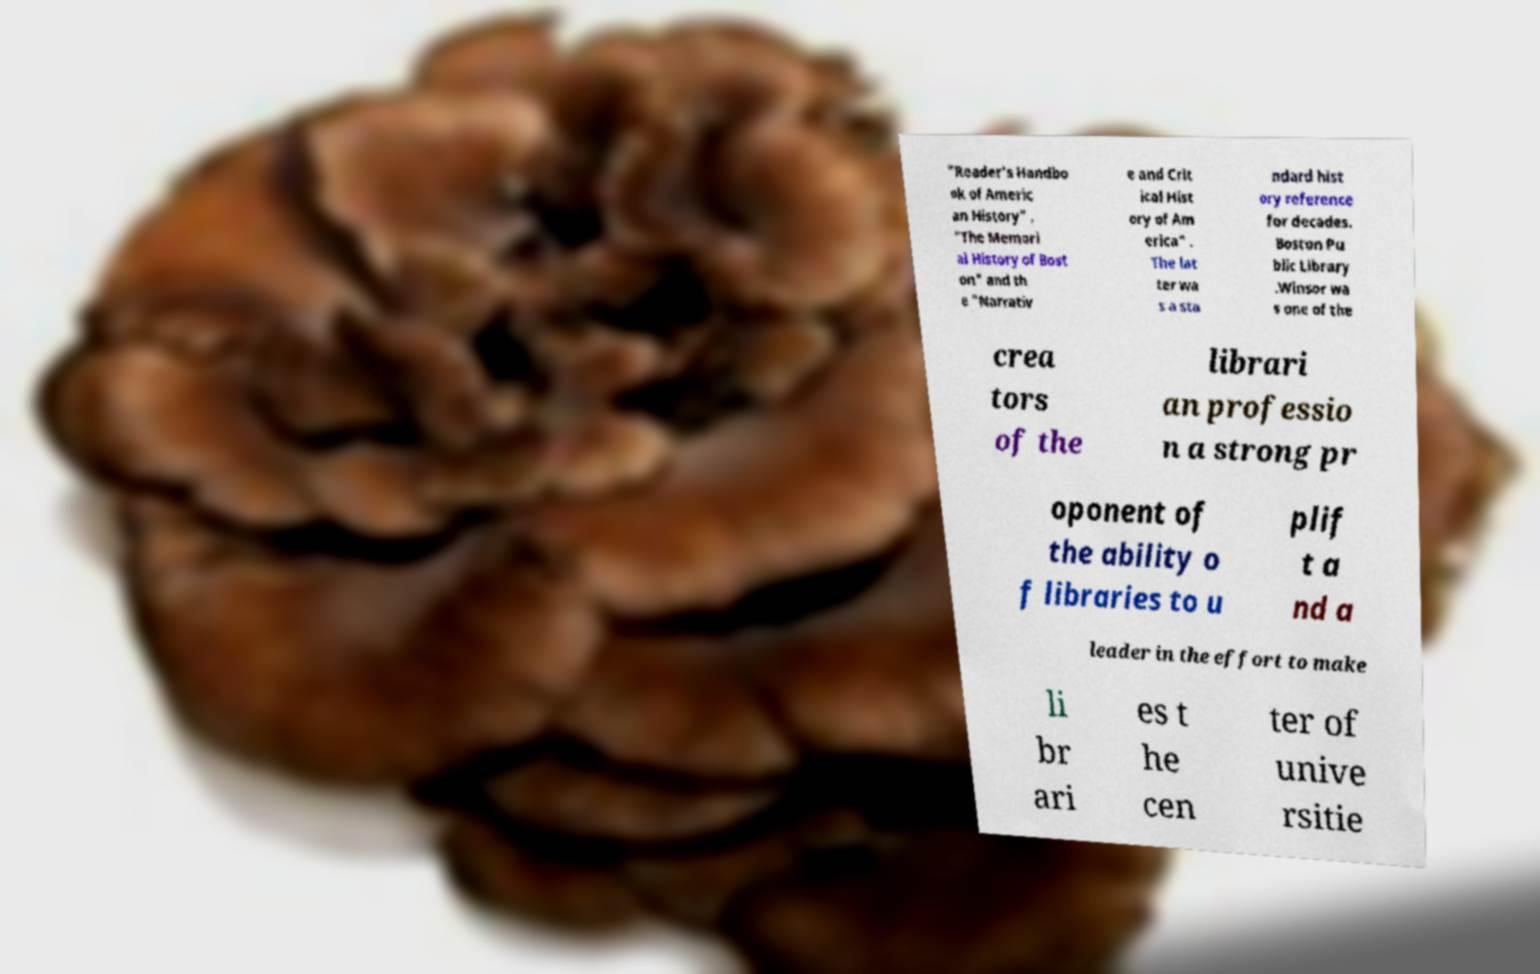What messages or text are displayed in this image? I need them in a readable, typed format. "Reader's Handbo ok of Americ an History" , "The Memori al History of Bost on" and th e "Narrativ e and Crit ical Hist ory of Am erica" . The lat ter wa s a sta ndard hist ory reference for decades. Boston Pu blic Library .Winsor wa s one of the crea tors of the librari an professio n a strong pr oponent of the ability o f libraries to u plif t a nd a leader in the effort to make li br ari es t he cen ter of unive rsitie 